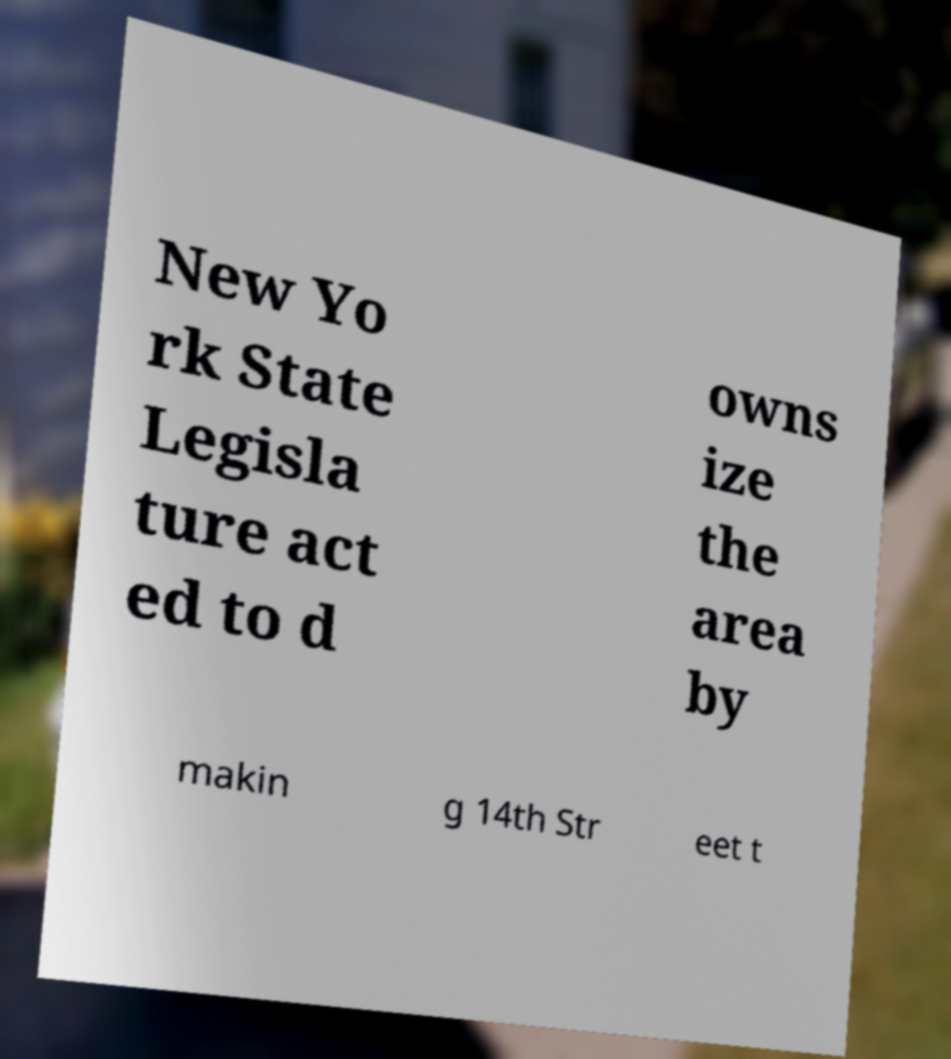There's text embedded in this image that I need extracted. Can you transcribe it verbatim? New Yo rk State Legisla ture act ed to d owns ize the area by makin g 14th Str eet t 